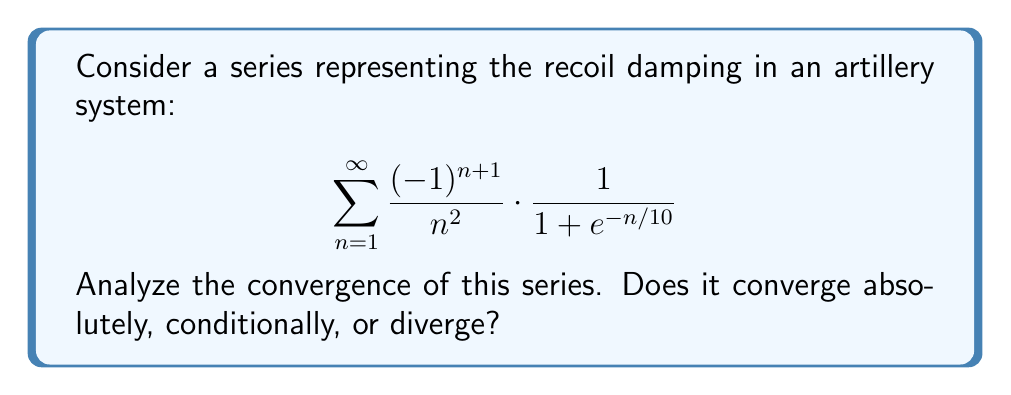Teach me how to tackle this problem. Let's approach this step-by-step:

1) First, let's consider the absolute convergence. We need to examine:

   $$\sum_{n=1}^{\infty} \left|\frac{(-1)^{n+1}}{n^2} \cdot \frac{1}{1 + e^{-n/10}}\right| = \sum_{n=1}^{\infty} \frac{1}{n^2} \cdot \frac{1}{1 + e^{-n/10}}$$

2) We can see that $\frac{1}{1 + e^{-n/10}}$ is always between 0 and 1, and approaches 1 as n increases.

3) Therefore, we can compare our series with the p-series $\sum_{n=1}^{\infty} \frac{1}{n^2}$:

   $$0 < \frac{1}{n^2} \cdot \frac{1}{1 + e^{-n/10}} < \frac{1}{n^2}$$

4) We know that $\sum_{n=1}^{\infty} \frac{1}{n^2}$ converges (it's the Basel problem, with sum $\frac{\pi^2}{6}$).

5) By the comparison test, our absolute series also converges.

6) Since the absolute series converges, the original alternating series must converge absolutely.

This result makes sense in the context of artillery recoil damping. The series represents decreasing oscillations that eventually settle, which is what we'd expect in a well-designed recoil system.
Answer: The series converges absolutely. 